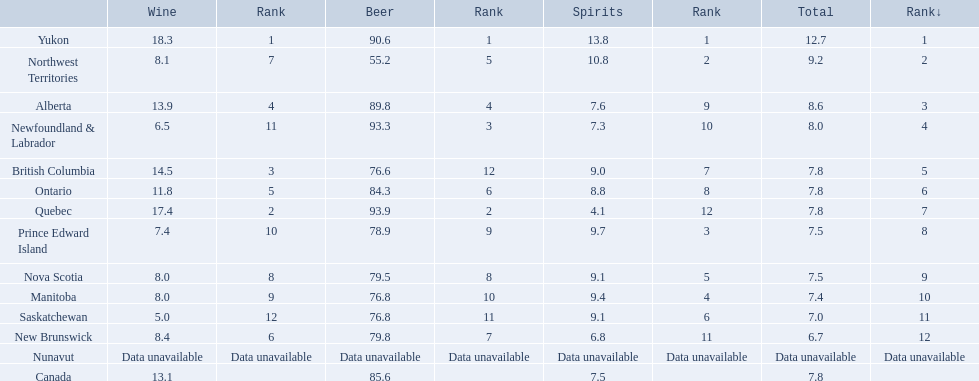In what region do people have the highest average consumption of spirits each year? Yukon. How many liters of spirits do individuals in this region typically consume per year? 12.7. 